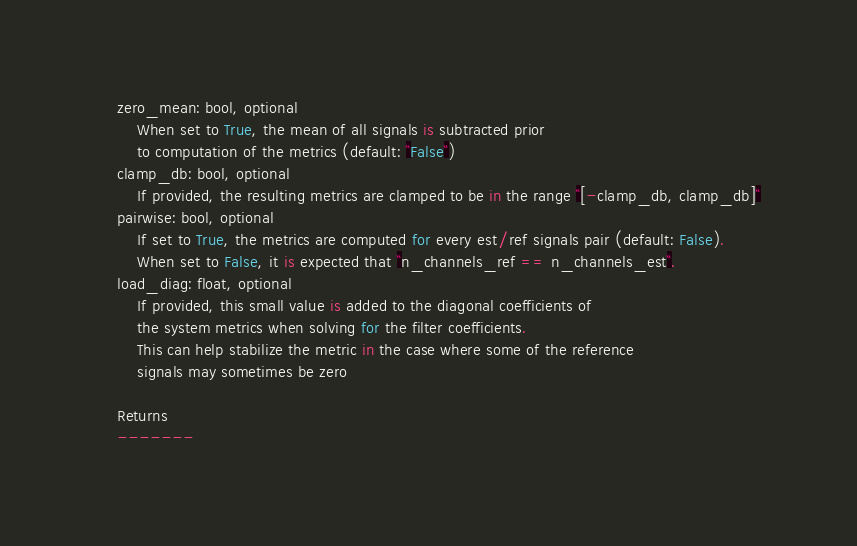Convert code to text. <code><loc_0><loc_0><loc_500><loc_500><_Python_>    zero_mean: bool, optional
        When set to True, the mean of all signals is subtracted prior
        to computation of the metrics (default: ``False``)
    clamp_db: bool, optional
        If provided, the resulting metrics are clamped to be in the range ``[-clamp_db, clamp_db]``
    pairwise: bool, optional
        If set to True, the metrics are computed for every est/ref signals pair (default: False).
        When set to False, it is expected that ``n_channels_ref == n_channels_est``.
    load_diag: float, optional
        If provided, this small value is added to the diagonal coefficients of
        the system metrics when solving for the filter coefficients.
        This can help stabilize the metric in the case where some of the reference
        signals may sometimes be zero

    Returns
    -------</code> 